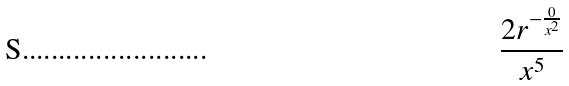Convert formula to latex. <formula><loc_0><loc_0><loc_500><loc_500>\frac { 2 r ^ { - \frac { 0 } { x ^ { 2 } } } } { x ^ { 5 } }</formula> 